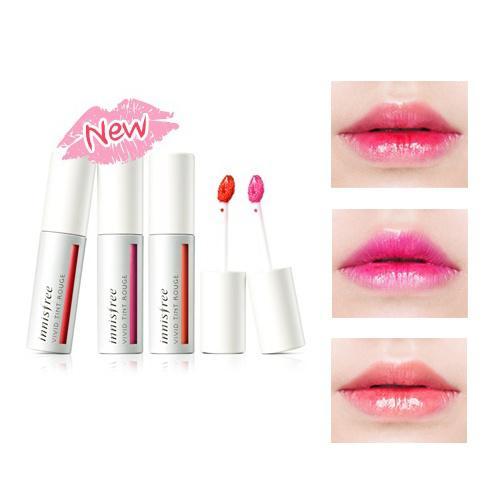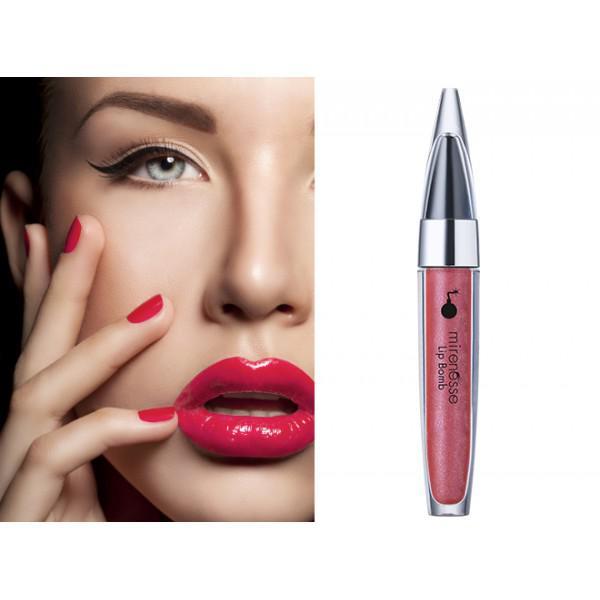The first image is the image on the left, the second image is the image on the right. Examine the images to the left and right. Is the description "In one image, a person's face is shown to demonstrate a specific lip color." accurate? Answer yes or no. Yes. 